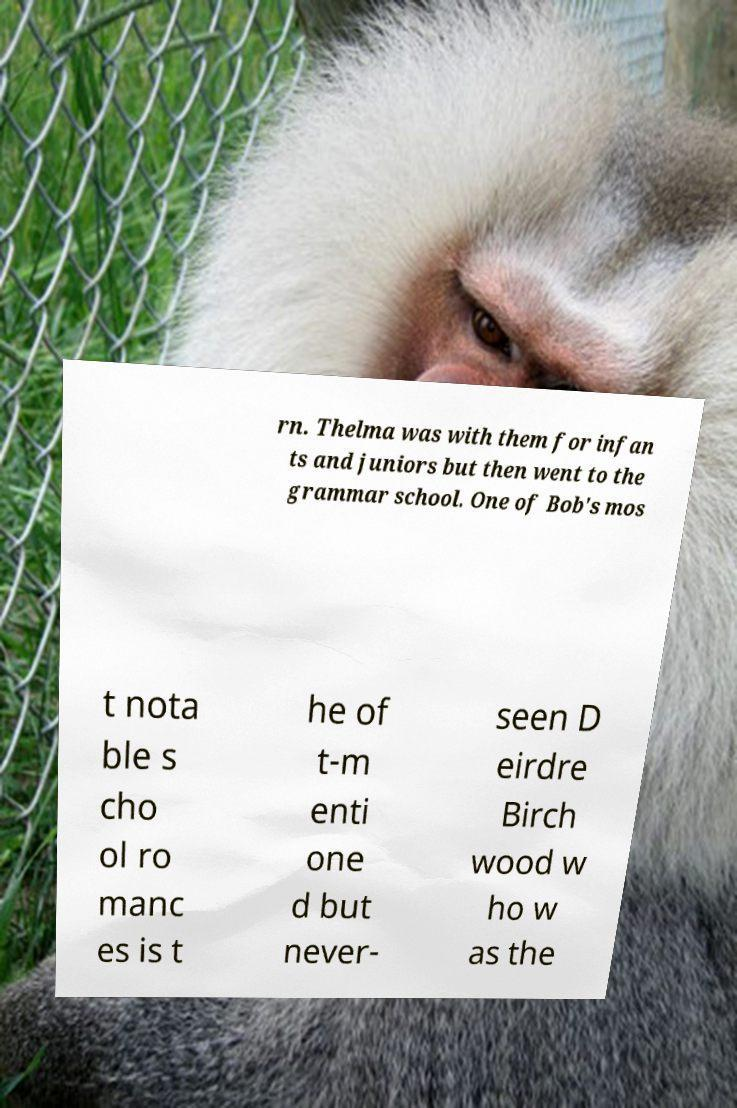Can you read and provide the text displayed in the image?This photo seems to have some interesting text. Can you extract and type it out for me? rn. Thelma was with them for infan ts and juniors but then went to the grammar school. One of Bob's mos t nota ble s cho ol ro manc es is t he of t-m enti one d but never- seen D eirdre Birch wood w ho w as the 